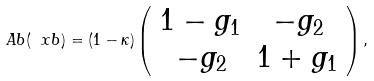<formula> <loc_0><loc_0><loc_500><loc_500>\ A b ( \ x b ) = ( 1 - \kappa ) \left ( \begin{array} { c c } 1 - g _ { 1 } & - g _ { 2 } \\ - g _ { 2 } & 1 + g _ { 1 } \end{array} \right ) ,</formula> 